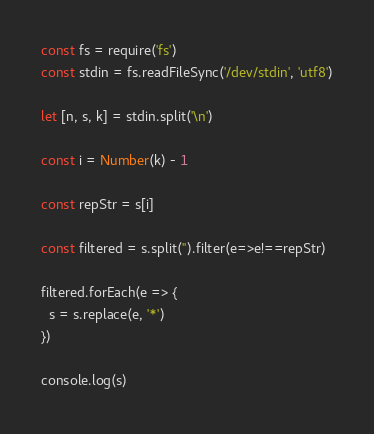<code> <loc_0><loc_0><loc_500><loc_500><_TypeScript_>const fs = require('fs')
const stdin = fs.readFileSync('/dev/stdin', 'utf8')

let [n, s, k] = stdin.split('\n')

const i = Number(k) - 1

const repStr = s[i]

const filtered = s.split('').filter(e=>e!==repStr)

filtered.forEach(e => {
  s = s.replace(e, '*')
})

console.log(s)
</code> 